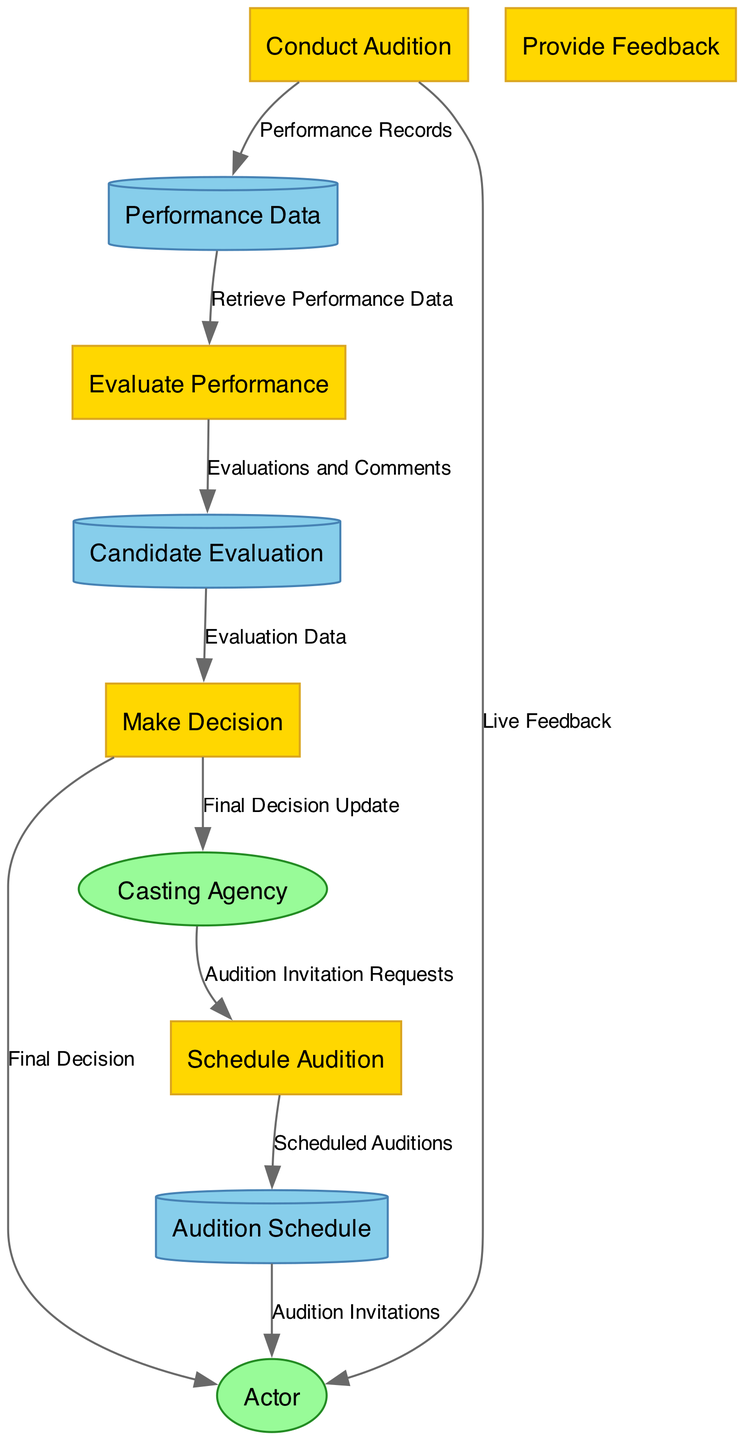What is the first process in the diagram? The first process listed in the diagram is "Schedule Audition". This can be identified by looking at the "processes" section, where the items are ordered, and "Schedule Audition" is the first entry.
Answer: Schedule Audition How many data stores are present? The diagram contains three data stores, which can be confirmed by counting the entries in the "dataStores" section.
Answer: 3 Which external entity requests audition slots? The external entity that requests audition slots is the "Casting Agency". This is indicated in the "dataFlows" section, where "Casting Agency" is sourced for the flow named "Audition Invitation Requests".
Answer: Casting Agency What kind of feedback do actors receive after the audition? Actors receive "Live Feedback" immediately after their audition. This is specified in the corresponding flow from "Conduct Audition" to "Actor".
Answer: Live Feedback Which process retrieves performance data for evaluation? The process that retrieves performance data is "Evaluate Performance". This can be established by looking at the flow that connects "Performance Data" data store to this process.
Answer: Evaluate Performance What is the last decision communicated to the actor? The last decision communicated to the actor is the "Final Decision". This is evident as the flow from "Make Decision" to "Actor" indicates that the decision on whether they were cast is provided.
Answer: Final Decision Which data store contains evaluations and comments? The data store that contains evaluations and comments is "Candidate Evaluation". This is clear from the flow where evaluations and comments from "Evaluate Performance" are stored in "Candidate Evaluation".
Answer: Candidate Evaluation What action does the casting director take after evaluating performance data? After evaluating performance data, the casting director performs the action of "Make Decision". This is found by following the data flow from "Evaluate Performance" to designation of this action in the diagram.
Answer: Make Decision What type of diagram is this? This is a Data Flow Diagram. This can be inferred from the title of the diagram itself, which indicates that it focuses on how data flows through different processes and entities involved in the audition and casting decision process.
Answer: Data Flow Diagram 